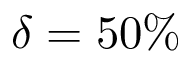<formula> <loc_0><loc_0><loc_500><loc_500>\delta = 5 0 \%</formula> 